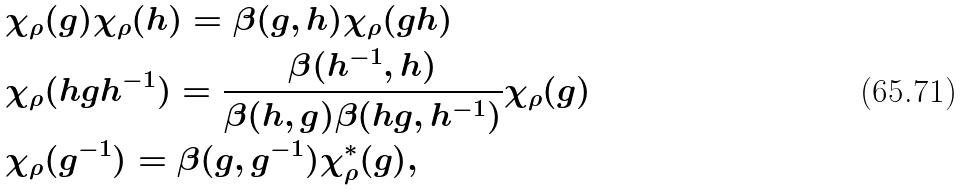Convert formula to latex. <formula><loc_0><loc_0><loc_500><loc_500>& \chi _ { \rho } ( g ) \chi _ { \rho } ( h ) = \beta ( g , h ) \chi _ { \rho } ( g h ) \\ & \chi _ { \rho } ( h g h ^ { - 1 } ) = \frac { \beta ( h ^ { - 1 } , h ) } { \beta ( h , g ) \beta ( h g , h ^ { - 1 } ) } \chi _ { \rho } ( g ) \\ & \chi _ { \rho } ( g ^ { - 1 } ) = \beta ( g , g ^ { - 1 } ) \chi ^ { * } _ { \rho } ( g ) ,</formula> 